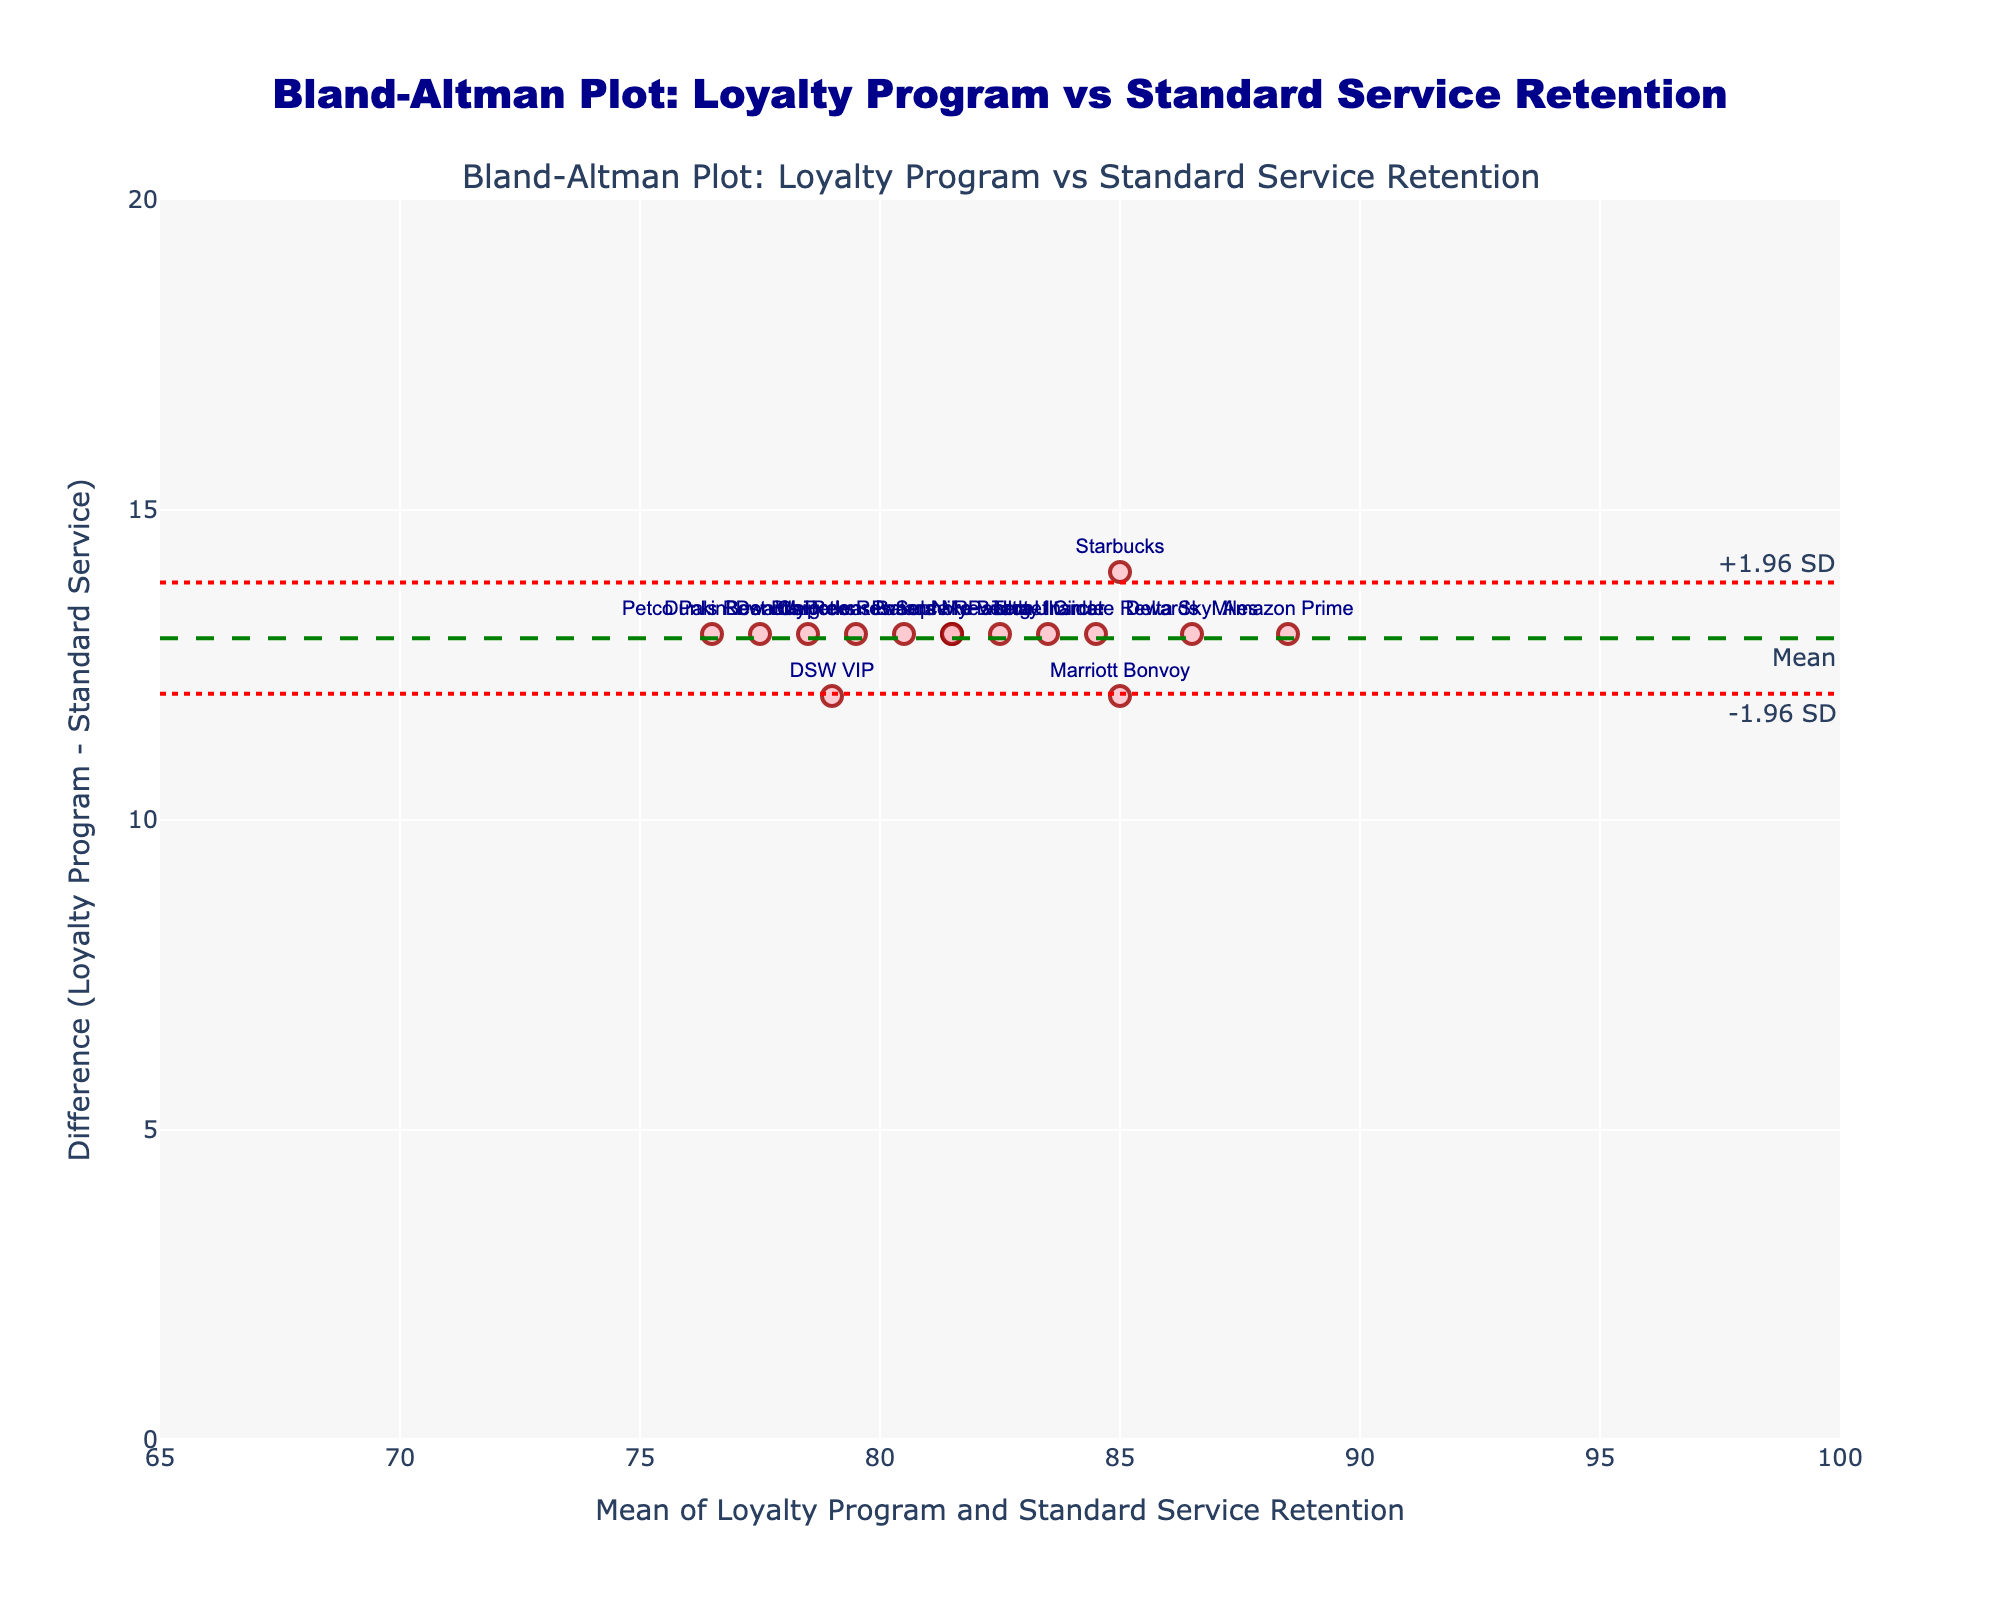What is the title of the Bland-Altman plot? The title is placed at the top center of the plot. It reads "Bland-Altman Plot: Loyalty Program vs Standard Service Retention".
Answer: Bland-Altman Plot: Loyalty Program vs Standard Service Retention How many customer data points are displayed on the plot? The plot displays a scatter of data points, each representing a customer. The count of these data points is the total number of customers in the data.
Answer: 15 What is the mean difference line value denoted in the plot? The mean difference line is highlighted with a dashed green line. The value is indicated next to the line.
Answer: ~12.5 What are the upper and lower limits of agreement in the plot? The upper and lower limits of agreement are marked by red dotted lines. The annotations near these lines display their values.
Answer: ~15.6 and ~9.4 Which customer shows the smallest difference between loyalty program and standard service retentions? By observing the scatter points on the y-axis, the customer point closest to zero represents the smallest difference.
Answer: Ulta Ultamate Rewards Which customer displays the highest mean retention rate between loyalty program and standard service? On the x-axis, the highest mean value point represents the highest averaged retention rate. Identifying the corresponding customer from the hover text helps answer this.
Answer: Amazon Prime Is there a customer whose loyalty program retention equals 95%? Looking at the scatter points and their corresponding annotations, we can identify which customer has this retention rate.
Answer: Amazon Prime Which customers lie outside the limits of agreement? We need to identify the customers whose points lie beyond the red dotted lines representing the limits of agreement.
Answer: None What is the range of mean retention rates on the x-axis? By examining the x-axis range marked by ticks, we can find the minimum and maximum mean retention rates plotted.
Answer: 65 to 100 How many customers have a difference in retention rate of exactly 15%? By counting the scatter points aligned with the 15 unit mark on the y-axis, we can determine the number of such customers.
Answer: 1 